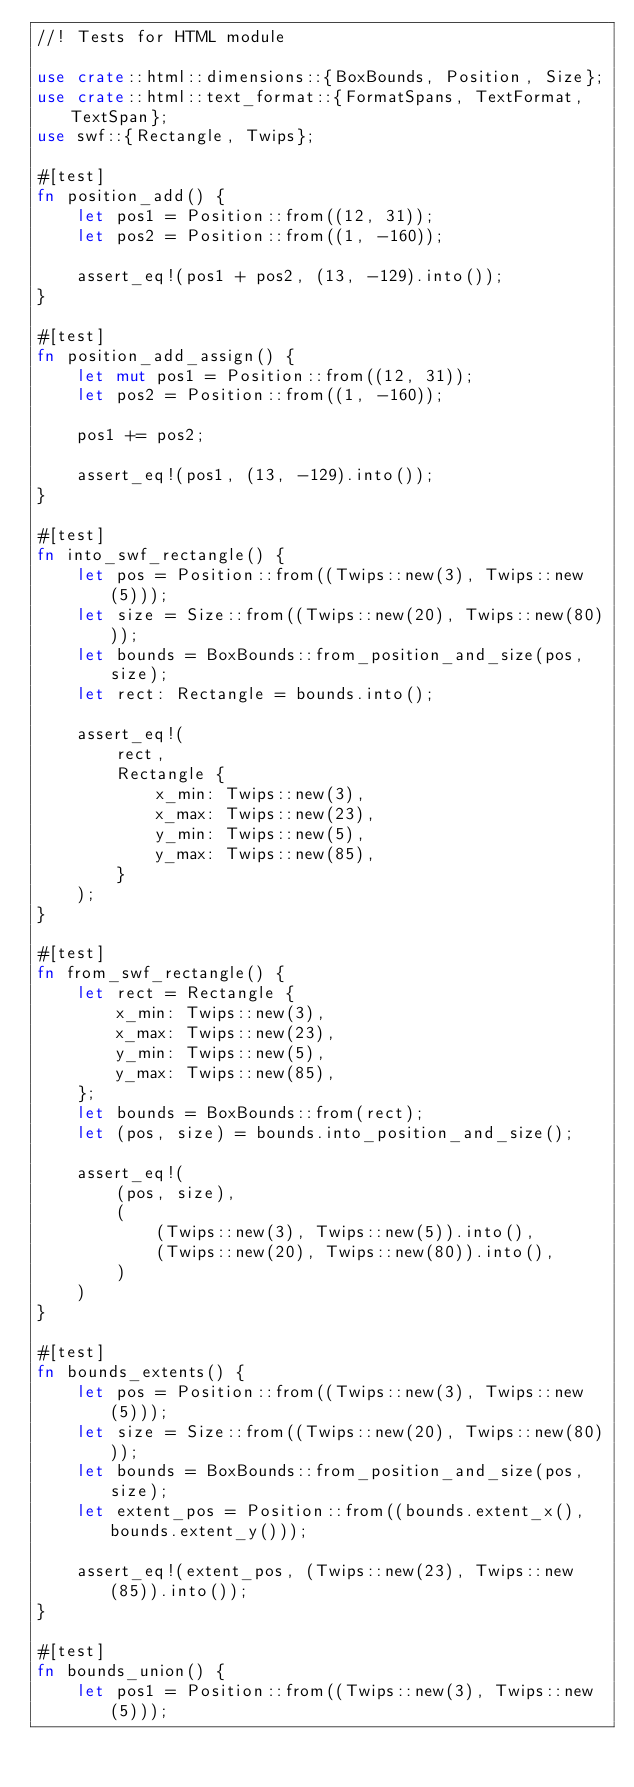<code> <loc_0><loc_0><loc_500><loc_500><_Rust_>//! Tests for HTML module

use crate::html::dimensions::{BoxBounds, Position, Size};
use crate::html::text_format::{FormatSpans, TextFormat, TextSpan};
use swf::{Rectangle, Twips};

#[test]
fn position_add() {
    let pos1 = Position::from((12, 31));
    let pos2 = Position::from((1, -160));

    assert_eq!(pos1 + pos2, (13, -129).into());
}

#[test]
fn position_add_assign() {
    let mut pos1 = Position::from((12, 31));
    let pos2 = Position::from((1, -160));

    pos1 += pos2;

    assert_eq!(pos1, (13, -129).into());
}

#[test]
fn into_swf_rectangle() {
    let pos = Position::from((Twips::new(3), Twips::new(5)));
    let size = Size::from((Twips::new(20), Twips::new(80)));
    let bounds = BoxBounds::from_position_and_size(pos, size);
    let rect: Rectangle = bounds.into();

    assert_eq!(
        rect,
        Rectangle {
            x_min: Twips::new(3),
            x_max: Twips::new(23),
            y_min: Twips::new(5),
            y_max: Twips::new(85),
        }
    );
}

#[test]
fn from_swf_rectangle() {
    let rect = Rectangle {
        x_min: Twips::new(3),
        x_max: Twips::new(23),
        y_min: Twips::new(5),
        y_max: Twips::new(85),
    };
    let bounds = BoxBounds::from(rect);
    let (pos, size) = bounds.into_position_and_size();

    assert_eq!(
        (pos, size),
        (
            (Twips::new(3), Twips::new(5)).into(),
            (Twips::new(20), Twips::new(80)).into(),
        )
    )
}

#[test]
fn bounds_extents() {
    let pos = Position::from((Twips::new(3), Twips::new(5)));
    let size = Size::from((Twips::new(20), Twips::new(80)));
    let bounds = BoxBounds::from_position_and_size(pos, size);
    let extent_pos = Position::from((bounds.extent_x(), bounds.extent_y()));

    assert_eq!(extent_pos, (Twips::new(23), Twips::new(85)).into());
}

#[test]
fn bounds_union() {
    let pos1 = Position::from((Twips::new(3), Twips::new(5)));</code> 